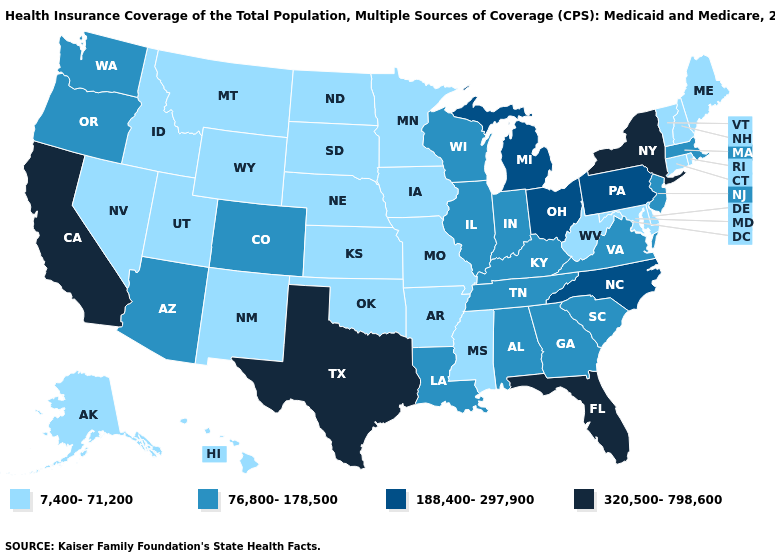Does Iowa have a lower value than California?
Keep it brief. Yes. Name the states that have a value in the range 188,400-297,900?
Keep it brief. Michigan, North Carolina, Ohio, Pennsylvania. Among the states that border Nebraska , which have the highest value?
Be succinct. Colorado. How many symbols are there in the legend?
Quick response, please. 4. What is the value of Kansas?
Write a very short answer. 7,400-71,200. Which states hav the highest value in the MidWest?
Quick response, please. Michigan, Ohio. What is the lowest value in the Northeast?
Keep it brief. 7,400-71,200. What is the lowest value in the West?
Short answer required. 7,400-71,200. What is the highest value in states that border Texas?
Write a very short answer. 76,800-178,500. Name the states that have a value in the range 188,400-297,900?
Write a very short answer. Michigan, North Carolina, Ohio, Pennsylvania. Name the states that have a value in the range 7,400-71,200?
Give a very brief answer. Alaska, Arkansas, Connecticut, Delaware, Hawaii, Idaho, Iowa, Kansas, Maine, Maryland, Minnesota, Mississippi, Missouri, Montana, Nebraska, Nevada, New Hampshire, New Mexico, North Dakota, Oklahoma, Rhode Island, South Dakota, Utah, Vermont, West Virginia, Wyoming. What is the highest value in the USA?
Answer briefly. 320,500-798,600. What is the highest value in the USA?
Concise answer only. 320,500-798,600. Which states hav the highest value in the South?
Write a very short answer. Florida, Texas. What is the value of Kentucky?
Concise answer only. 76,800-178,500. 